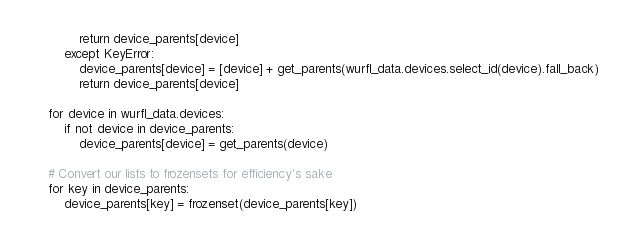Convert code to text. <code><loc_0><loc_0><loc_500><loc_500><_Python_>            return device_parents[device]
        except KeyError:
            device_parents[device] = [device] + get_parents(wurfl_data.devices.select_id(device).fall_back)
            return device_parents[device]

    for device in wurfl_data.devices:
        if not device in device_parents:
            device_parents[device] = get_parents(device)
        
    # Convert our lists to frozensets for efficiency's sake
    for key in device_parents:
        device_parents[key] = frozenset(device_parents[key])
</code> 